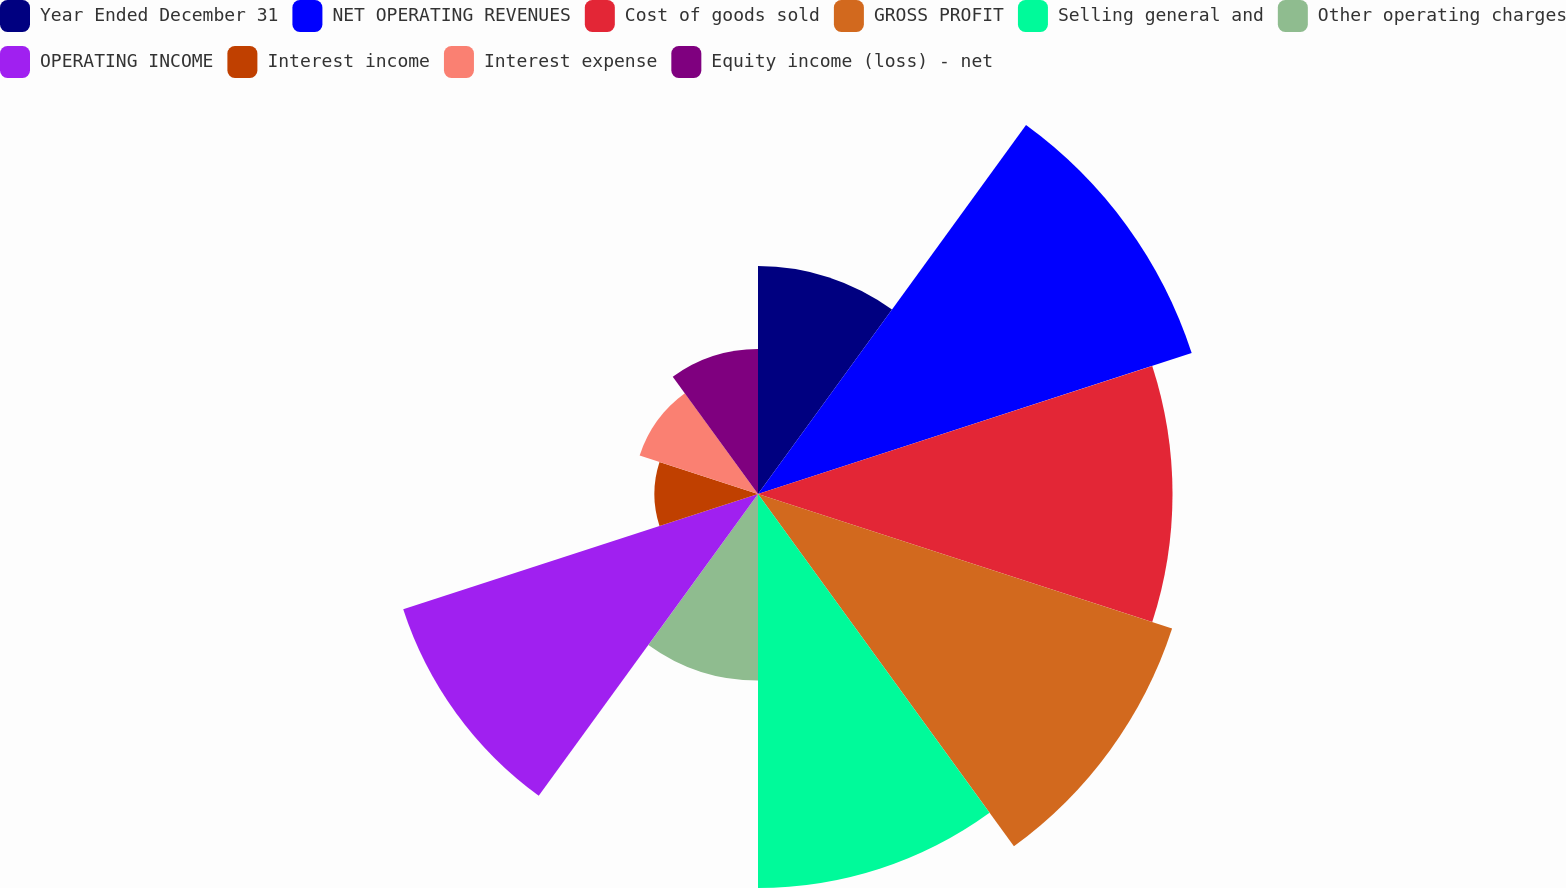<chart> <loc_0><loc_0><loc_500><loc_500><pie_chart><fcel>Year Ended December 31<fcel>NET OPERATING REVENUES<fcel>Cost of goods sold<fcel>GROSS PROFIT<fcel>Selling general and<fcel>Other operating charges<fcel>OPERATING INCOME<fcel>Interest income<fcel>Interest expense<fcel>Equity income (loss) - net<nl><fcel>7.97%<fcel>15.94%<fcel>14.49%<fcel>15.22%<fcel>13.77%<fcel>6.52%<fcel>13.04%<fcel>3.62%<fcel>4.35%<fcel>5.07%<nl></chart> 